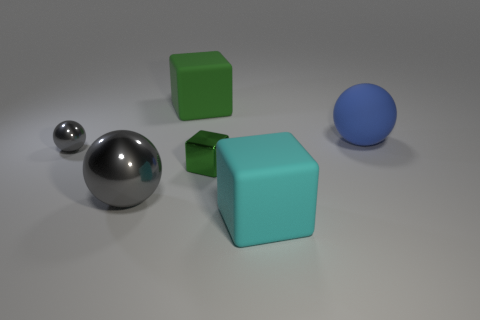Subtract all gray cubes. Subtract all red cylinders. How many cubes are left? 3 Add 4 tiny green blocks. How many objects exist? 10 Add 2 big gray metal objects. How many big gray metal objects exist? 3 Subtract 1 blue spheres. How many objects are left? 5 Subtract all big matte cubes. Subtract all big balls. How many objects are left? 2 Add 5 large green matte cubes. How many large green matte cubes are left? 6 